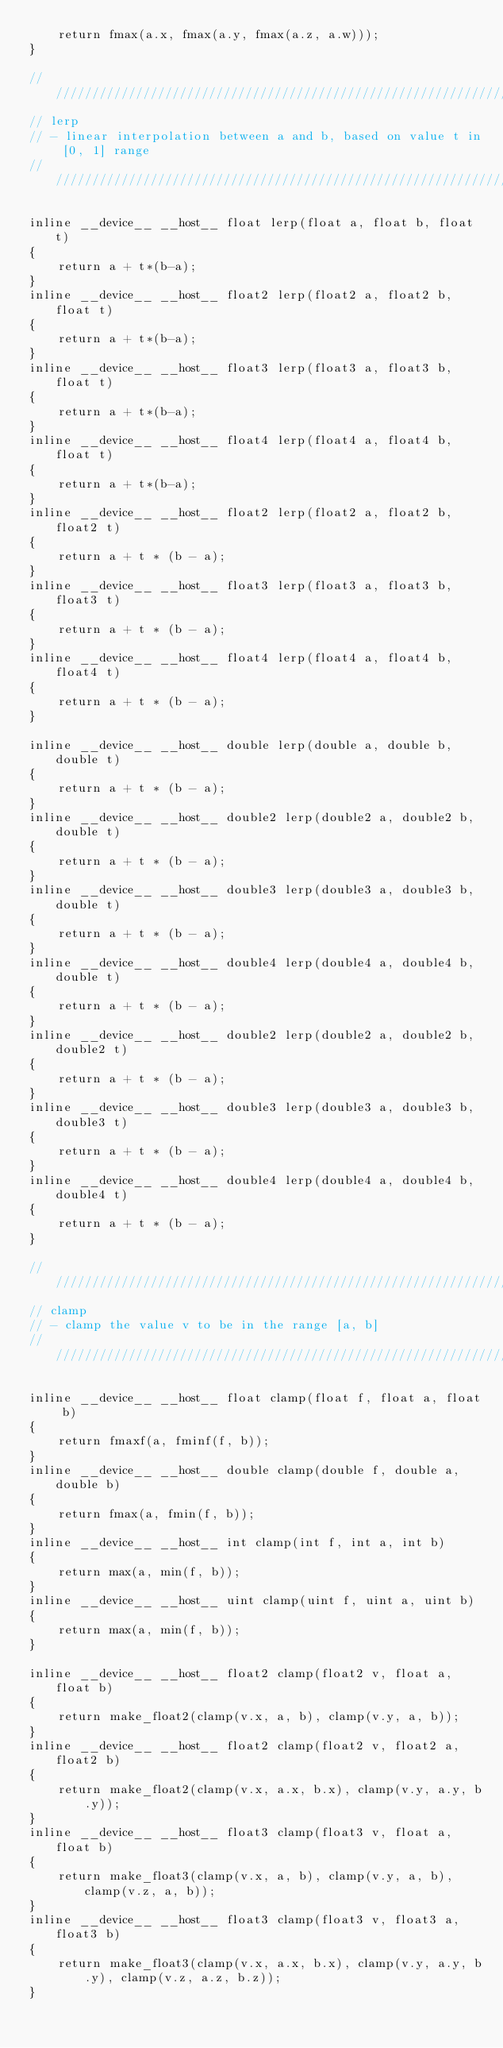Convert code to text. <code><loc_0><loc_0><loc_500><loc_500><_Cuda_>    return fmax(a.x, fmax(a.y, fmax(a.z, a.w)));
}

////////////////////////////////////////////////////////////////////////////////
// lerp
// - linear interpolation between a and b, based on value t in [0, 1] range
////////////////////////////////////////////////////////////////////////////////

inline __device__ __host__ float lerp(float a, float b, float t)
{
    return a + t*(b-a);
}
inline __device__ __host__ float2 lerp(float2 a, float2 b, float t)
{
    return a + t*(b-a);
}
inline __device__ __host__ float3 lerp(float3 a, float3 b, float t)
{
    return a + t*(b-a);
}
inline __device__ __host__ float4 lerp(float4 a, float4 b, float t)
{
    return a + t*(b-a);
}
inline __device__ __host__ float2 lerp(float2 a, float2 b, float2 t)
{
    return a + t * (b - a);
}
inline __device__ __host__ float3 lerp(float3 a, float3 b, float3 t)
{
    return a + t * (b - a);
}
inline __device__ __host__ float4 lerp(float4 a, float4 b, float4 t)
{
    return a + t * (b - a);
}

inline __device__ __host__ double lerp(double a, double b, double t)
{
    return a + t * (b - a);
}
inline __device__ __host__ double2 lerp(double2 a, double2 b, double t)
{
    return a + t * (b - a);
}
inline __device__ __host__ double3 lerp(double3 a, double3 b, double t)
{
    return a + t * (b - a);
}
inline __device__ __host__ double4 lerp(double4 a, double4 b, double t)
{
    return a + t * (b - a);
}
inline __device__ __host__ double2 lerp(double2 a, double2 b, double2 t)
{
    return a + t * (b - a);
}
inline __device__ __host__ double3 lerp(double3 a, double3 b, double3 t)
{
    return a + t * (b - a);
}
inline __device__ __host__ double4 lerp(double4 a, double4 b, double4 t)
{
    return a + t * (b - a);
}

////////////////////////////////////////////////////////////////////////////////
// clamp
// - clamp the value v to be in the range [a, b]
////////////////////////////////////////////////////////////////////////////////

inline __device__ __host__ float clamp(float f, float a, float b)
{
    return fmaxf(a, fminf(f, b));
}
inline __device__ __host__ double clamp(double f, double a, double b)
{
    return fmax(a, fmin(f, b));
}
inline __device__ __host__ int clamp(int f, int a, int b)
{
    return max(a, min(f, b));
}
inline __device__ __host__ uint clamp(uint f, uint a, uint b)
{
    return max(a, min(f, b));
}

inline __device__ __host__ float2 clamp(float2 v, float a, float b)
{
    return make_float2(clamp(v.x, a, b), clamp(v.y, a, b));
}
inline __device__ __host__ float2 clamp(float2 v, float2 a, float2 b)
{
    return make_float2(clamp(v.x, a.x, b.x), clamp(v.y, a.y, b.y));
}
inline __device__ __host__ float3 clamp(float3 v, float a, float b)
{
    return make_float3(clamp(v.x, a, b), clamp(v.y, a, b), clamp(v.z, a, b));
}
inline __device__ __host__ float3 clamp(float3 v, float3 a, float3 b)
{
    return make_float3(clamp(v.x, a.x, b.x), clamp(v.y, a.y, b.y), clamp(v.z, a.z, b.z));
}</code> 